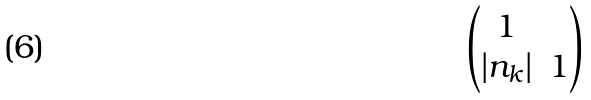Convert formula to latex. <formula><loc_0><loc_0><loc_500><loc_500>\begin{pmatrix} 1 & \\ | n _ { k } | & 1 \end{pmatrix}</formula> 